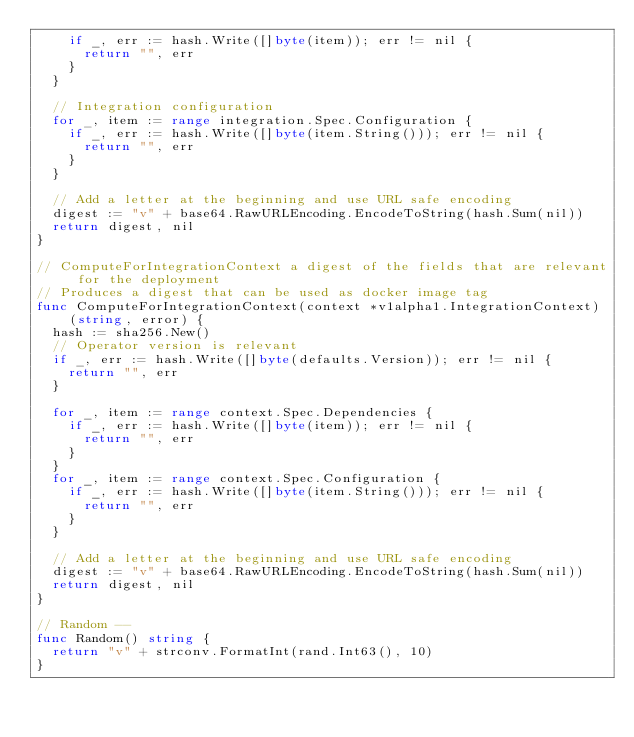Convert code to text. <code><loc_0><loc_0><loc_500><loc_500><_Go_>		if _, err := hash.Write([]byte(item)); err != nil {
			return "", err
		}
	}

	// Integration configuration
	for _, item := range integration.Spec.Configuration {
		if _, err := hash.Write([]byte(item.String())); err != nil {
			return "", err
		}
	}

	// Add a letter at the beginning and use URL safe encoding
	digest := "v" + base64.RawURLEncoding.EncodeToString(hash.Sum(nil))
	return digest, nil
}

// ComputeForIntegrationContext a digest of the fields that are relevant for the deployment
// Produces a digest that can be used as docker image tag
func ComputeForIntegrationContext(context *v1alpha1.IntegrationContext) (string, error) {
	hash := sha256.New()
	// Operator version is relevant
	if _, err := hash.Write([]byte(defaults.Version)); err != nil {
		return "", err
	}

	for _, item := range context.Spec.Dependencies {
		if _, err := hash.Write([]byte(item)); err != nil {
			return "", err
		}
	}
	for _, item := range context.Spec.Configuration {
		if _, err := hash.Write([]byte(item.String())); err != nil {
			return "", err
		}
	}

	// Add a letter at the beginning and use URL safe encoding
	digest := "v" + base64.RawURLEncoding.EncodeToString(hash.Sum(nil))
	return digest, nil
}

// Random --
func Random() string {
	return "v" + strconv.FormatInt(rand.Int63(), 10)
}
</code> 